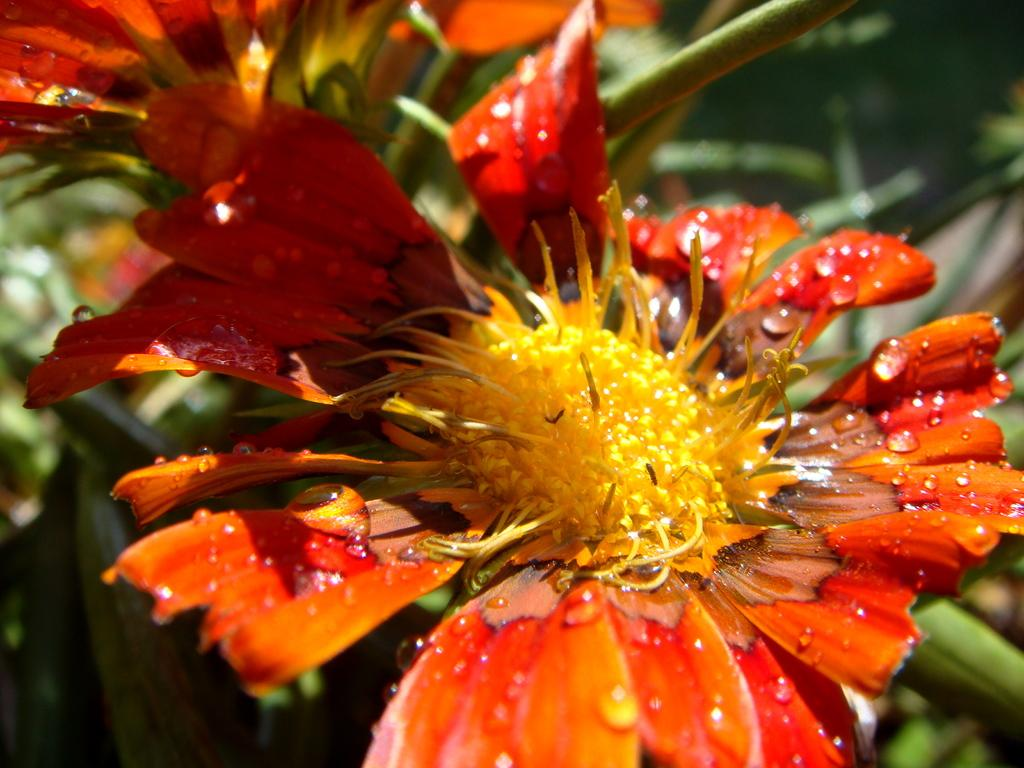What type of flowers can be seen in the image? There are red color flowers in the image. Is there a squirrel biting into one of the flowers in the image? No, there is no squirrel or any indication of biting in the image; it only features red color flowers. 